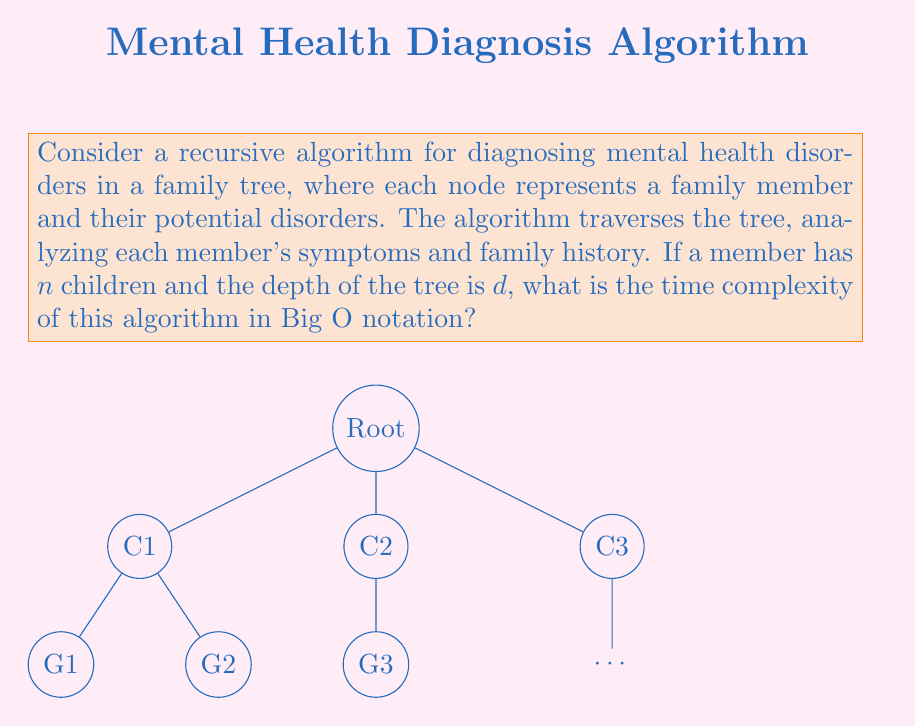Teach me how to tackle this problem. To analyze the time complexity of this recursive algorithm, let's break it down step-by-step:

1) At each node (family member), the algorithm performs some constant-time operations to analyze symptoms and family history. Let's call this constant time $c$.

2) For each node, the algorithm then recursively calls itself for all children of that node.

3) The number of nodes at each level of the tree increases by a factor of $n$ (the number of children per node).

4) The depth of the tree is $d$, which means there are $d+1$ levels (counting the root as level 0).

5) The total number of nodes in the tree can be expressed as:

   $1 + n + n^2 + n^3 + ... + n^d = \sum_{i=0}^d n^i$

6) This is a geometric series with $d+1$ terms. The sum of this series is given by the formula:

   $S = \frac{1-n^{d+1}}{1-n}$ (when $n \neq 1$)

7) As $n > 1$ (assuming each member has at least one child on average), for large $d$, this sum is dominated by $n^d$.

8) Therefore, the total number of nodes is $O(n^d)$.

9) As we perform constant time operations at each node, the total time complexity is also $O(n^d)$.

Thus, the time complexity of this recursive algorithm is $O(n^d)$, where $n$ is the number of children per node and $d$ is the depth of the tree.
Answer: $O(n^d)$ 